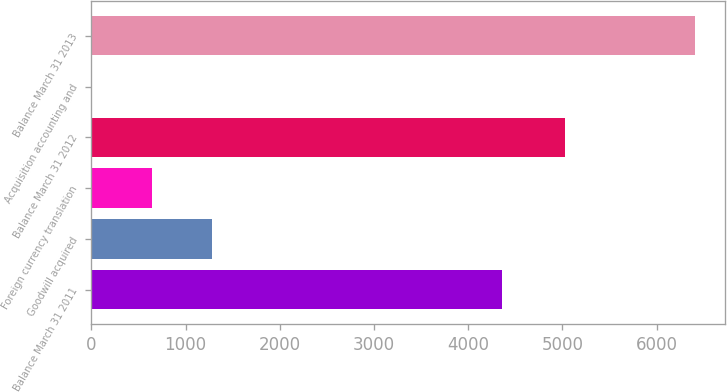<chart> <loc_0><loc_0><loc_500><loc_500><bar_chart><fcel>Balance March 31 2011<fcel>Goodwill acquired<fcel>Foreign currency translation<fcel>Balance March 31 2012<fcel>Acquisition accounting and<fcel>Balance March 31 2013<nl><fcel>4364<fcel>1285<fcel>645<fcel>5032<fcel>5<fcel>6405<nl></chart> 